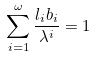<formula> <loc_0><loc_0><loc_500><loc_500>\sum _ { i = 1 } ^ { \omega } \frac { l _ { i } b _ { i } } { \lambda ^ { i } } = 1</formula> 